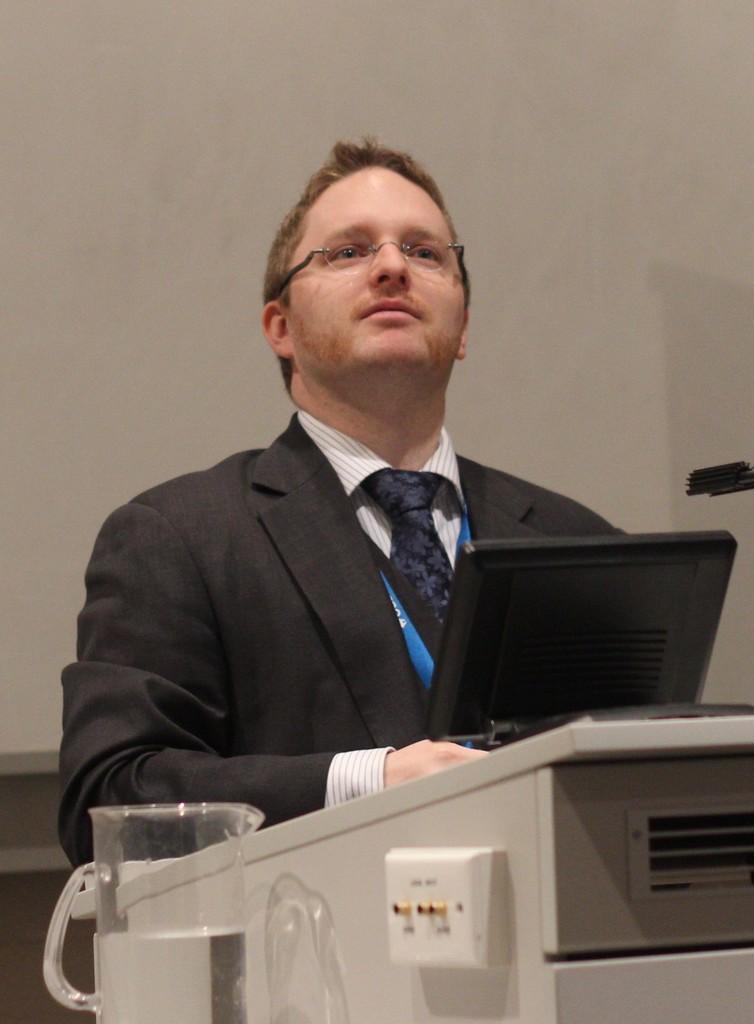Please provide a concise description of this image. In this picture I can see a man standing and a water jug on the left side and it looks like a podium at the bottom of the picture and looks like a tablet on the podium and a wall in the background. 